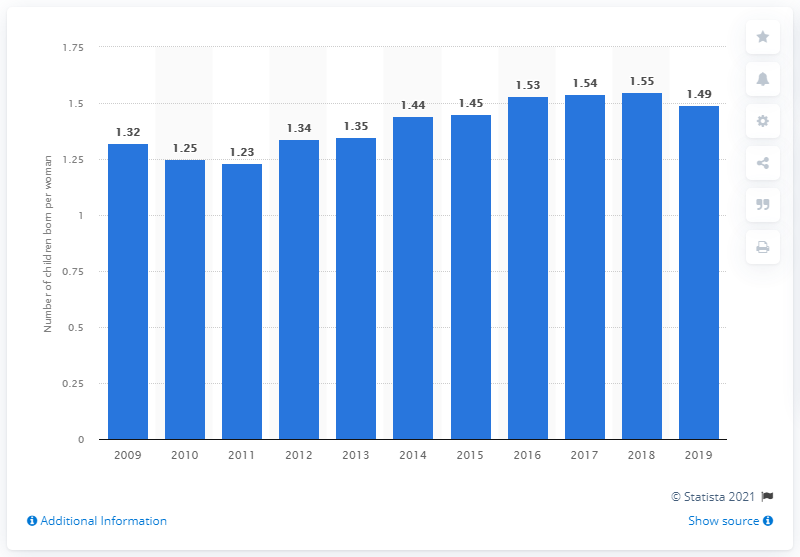Give some essential details in this illustration. In 2019, the fertility rate in Hungary was 1.49, which represents a continued decline in the number of children being born per woman. 